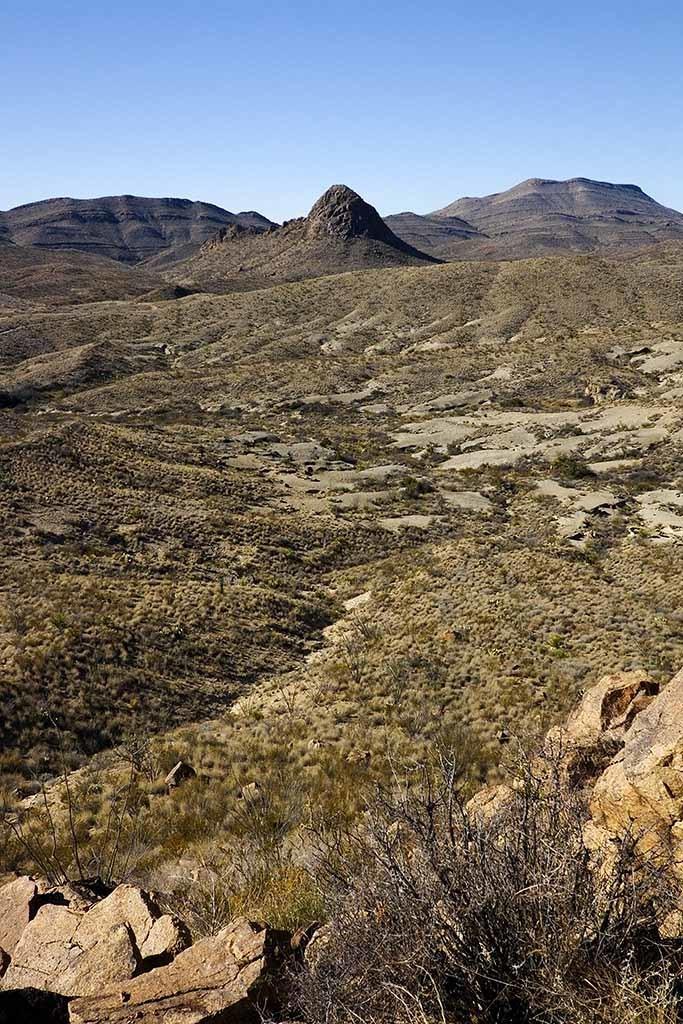How would you summarize this image in a sentence or two? In the image we can see stones, grass, dry plant, hills and the pale blue sky. 